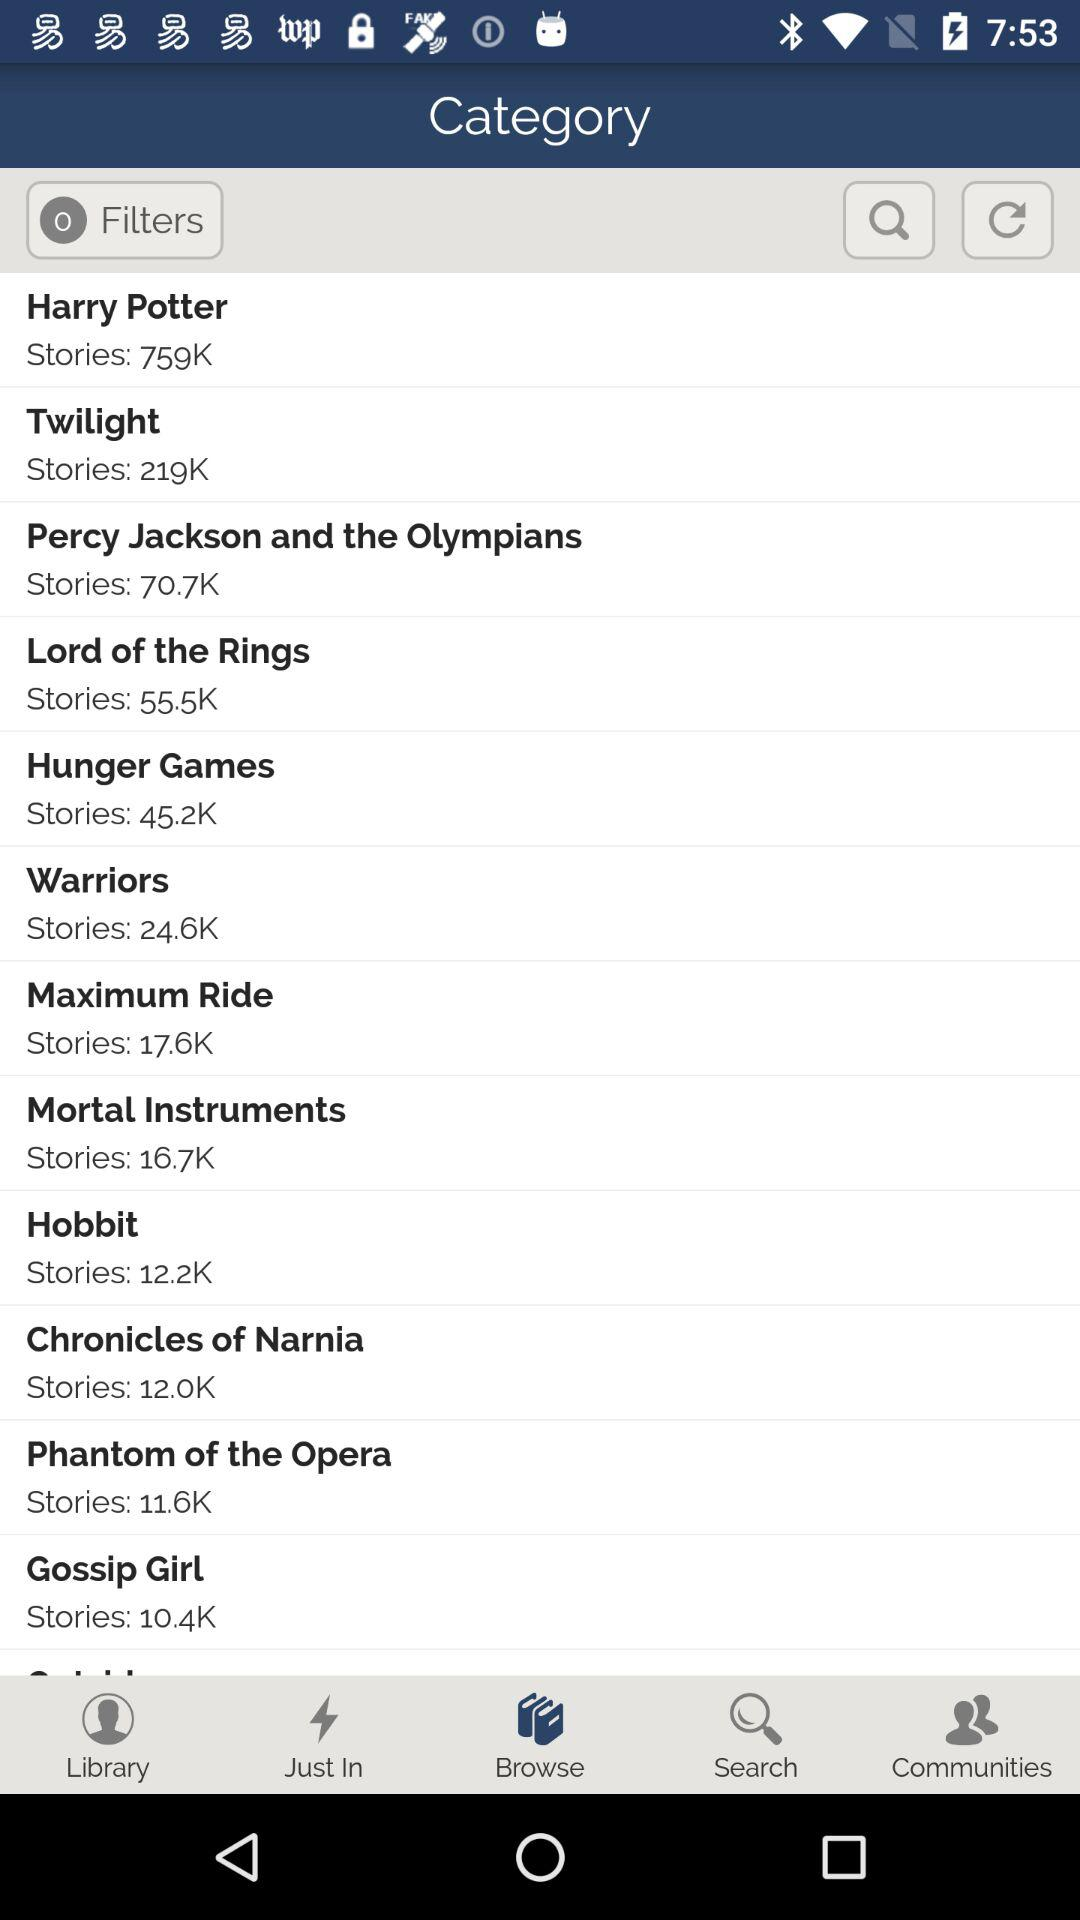What is the number of stories in "Hobbit"? There are 12,200 stories. 